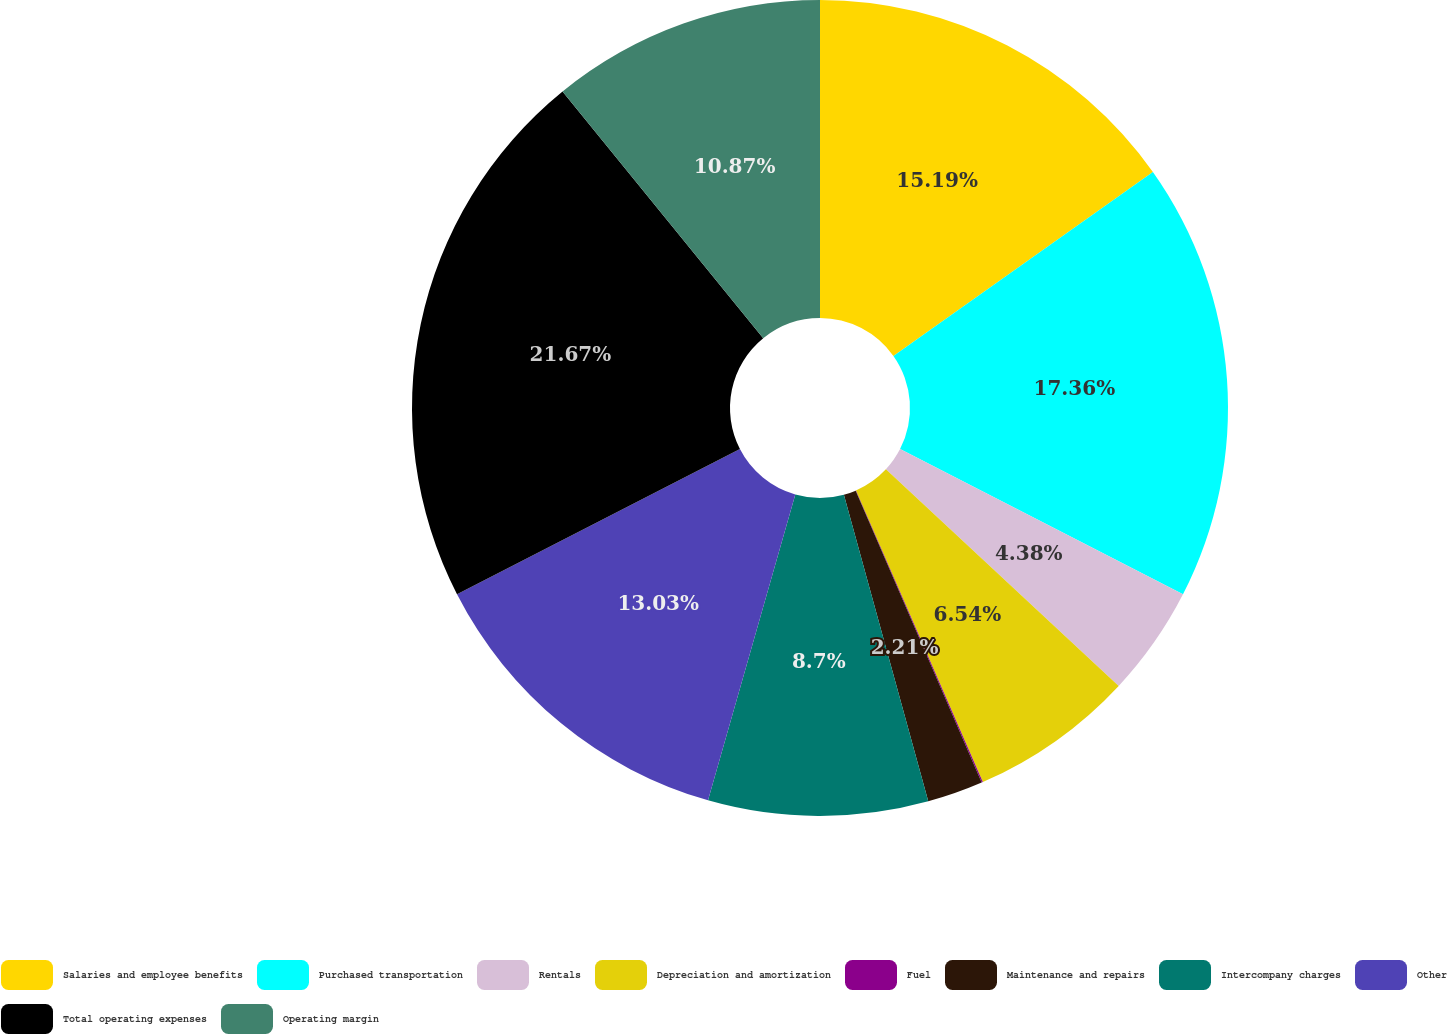<chart> <loc_0><loc_0><loc_500><loc_500><pie_chart><fcel>Salaries and employee benefits<fcel>Purchased transportation<fcel>Rentals<fcel>Depreciation and amortization<fcel>Fuel<fcel>Maintenance and repairs<fcel>Intercompany charges<fcel>Other<fcel>Total operating expenses<fcel>Operating margin<nl><fcel>15.19%<fcel>17.36%<fcel>4.38%<fcel>6.54%<fcel>0.05%<fcel>2.21%<fcel>8.7%<fcel>13.03%<fcel>21.68%<fcel>10.87%<nl></chart> 